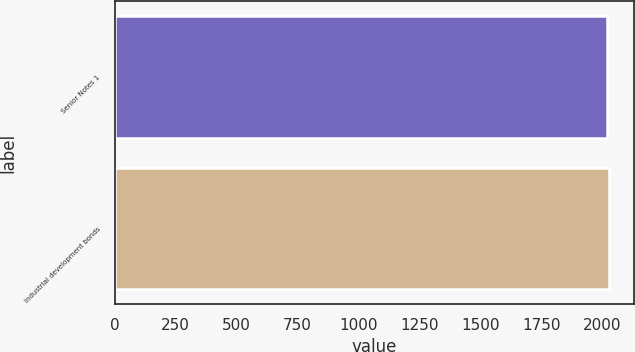Convert chart to OTSL. <chart><loc_0><loc_0><loc_500><loc_500><bar_chart><fcel>Senior Notes 1<fcel>Industrial development bonds<nl><fcel>2022<fcel>2030<nl></chart> 